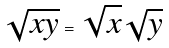Convert formula to latex. <formula><loc_0><loc_0><loc_500><loc_500>\sqrt { x y } = \sqrt { x } \sqrt { y }</formula> 